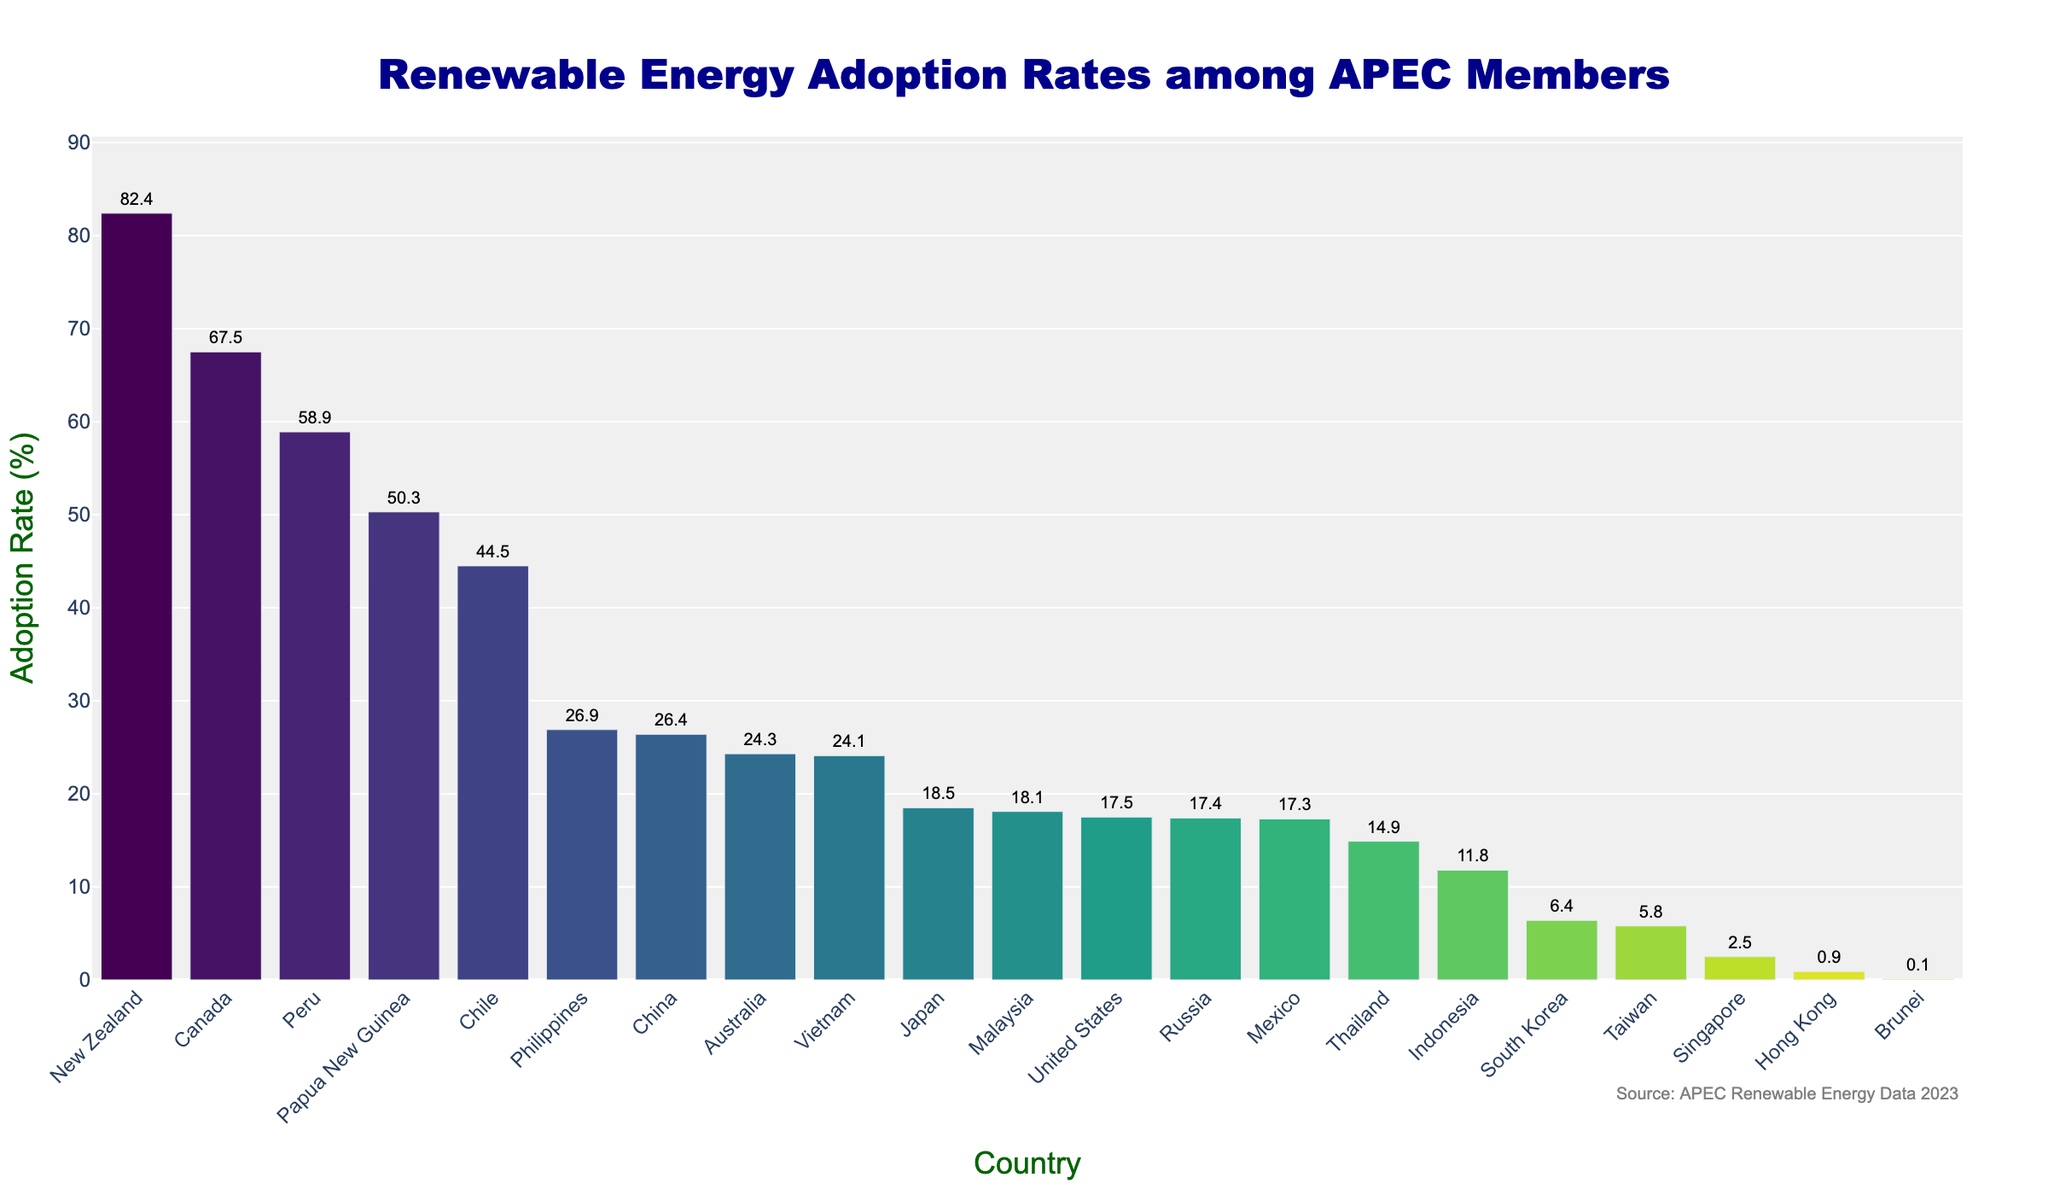Which country has the highest renewable energy adoption rate among APEC members? By inspecting the height of the bars, the tallest bar represents New Zealand. The adoption rate for New Zealand is 82.4%.
Answer: New Zealand How does the renewable energy adoption rate of Canada compare to that of the United States? Observing the heights and the associated values of the bars, Canada's adoption rate is 67.5%, while the United States' adoption rate is 17.5%. Thus, Canada’s adoption rate is significantly higher.
Answer: Canada is higher What is the combined renewable energy adoption rate of the top three countries? The top three countries are New Zealand (82.4%), Canada (67.5%), and Peru (58.9%). Adding these rates: 82.4 + 67.5 + 58.9 = 208.8%.
Answer: 208.8% Which country among APEC members has the lowest renewable energy adoption rate? The shortest bar represents Brunei with an adoption rate of 0.1%.
Answer: Brunei What is the difference in renewable energy adoption rates between China and Japan? China has an adoption rate of 26.4%, while Japan has 18.5%. The difference is 26.4 - 18.5 = 7.9%.
Answer: 7.9% What is the median renewable energy adoption rate? To find the median, first rank all countries' adoption rates. The middle value when sorted is the median. Sorted rates: 0.1, 0.9, 2.5, 5.8, 6.4, 11.8, 14.9, 17.3, 17.4, 17.5, 18.1, 18.5, 24.1, 24.3, 26.4, 26.9, 44.5, 50.3, 58.9, 67.5, 82.4. The median (11th value) is 18.1%.
Answer: 18.1% How does the renewable energy adoption rate of Vietnam compare to that of Australia? Vietnam's adoption rate is 24.1%, slightly below Australia's 24.3%, according to the bar heights and labels.
Answer: Vietnam is lower Which countries have a renewable energy adoption rate below 10%? The bars with heights below 10% represent Brunei (0.1%), Hong Kong (0.9%), Singapore (2.5%), and Taiwan (5.8%).
Answer: Brunei, Hong Kong, Singapore, Taiwan If the average renewable energy adoption rate across all APEC members is calculated, what should it be? Sum all rates and divide by the number of countries (21). Total sum: 543.0%. Average: 543.0 / 21 = 25.9%.
Answer: 25.9% What is the range of renewable energy adoption rates among APEC members? The range is the difference between the maximum (New Zealand, 82.4%) and the minimum (Brunei, 0.1%) rates. 82.4 - 0.1 = 82.3%.
Answer: 82.3% 